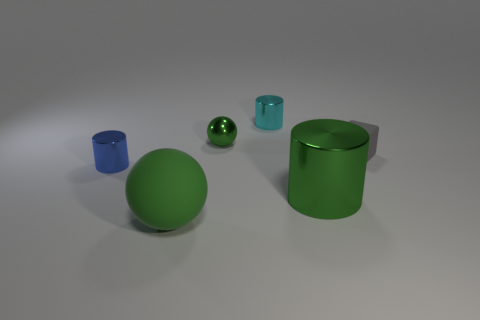Add 2 large cyan rubber cylinders. How many objects exist? 8 Subtract all blocks. How many objects are left? 5 Add 2 big red rubber things. How many big red rubber things exist? 2 Subtract 0 brown cylinders. How many objects are left? 6 Subtract all tiny shiny things. Subtract all small gray objects. How many objects are left? 2 Add 2 small blue things. How many small blue things are left? 3 